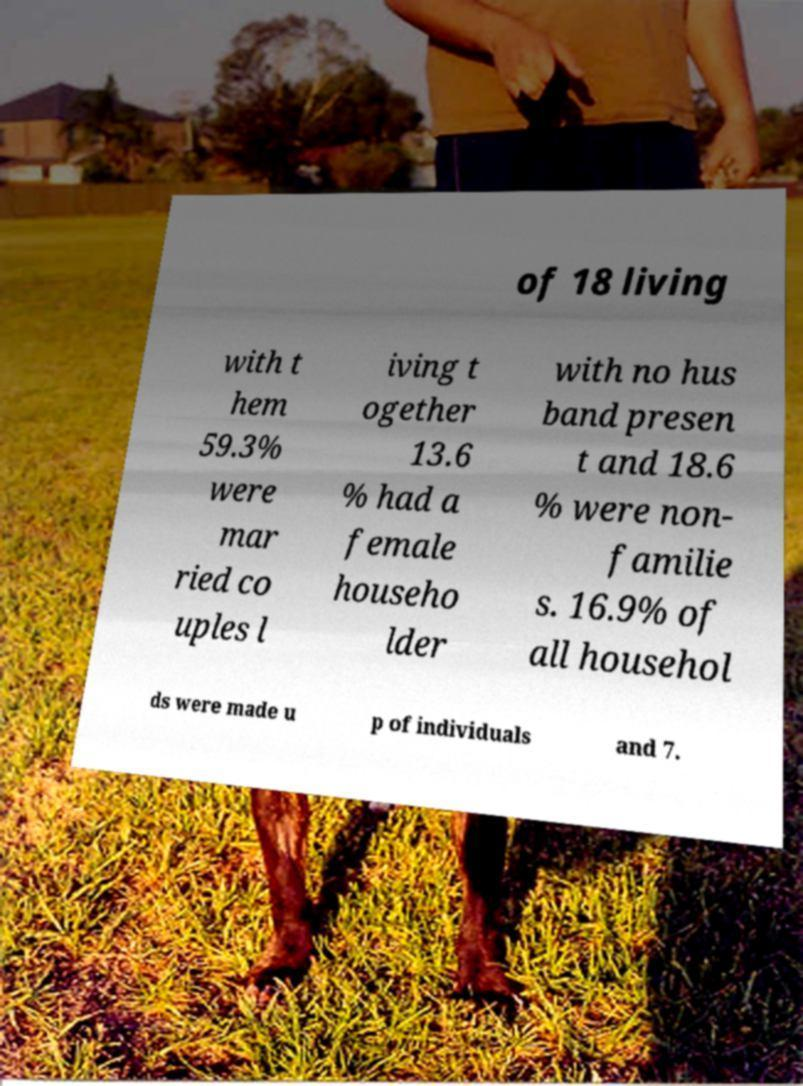Could you extract and type out the text from this image? of 18 living with t hem 59.3% were mar ried co uples l iving t ogether 13.6 % had a female househo lder with no hus band presen t and 18.6 % were non- familie s. 16.9% of all househol ds were made u p of individuals and 7. 